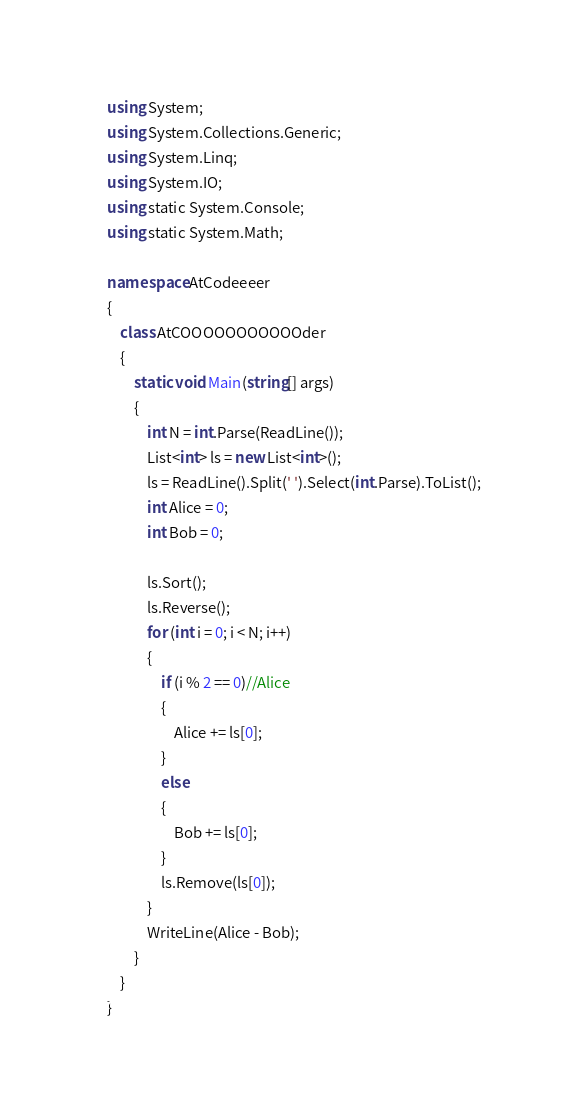<code> <loc_0><loc_0><loc_500><loc_500><_C#_>using System;
using System.Collections.Generic;
using System.Linq;
using System.IO;
using static System.Console;
using static System.Math;

namespace AtCodeeeer
{
    class AtCOOOOOOOOOOOder
    {
        static void Main(string[] args)
        {
            int N = int.Parse(ReadLine());
            List<int> ls = new List<int>();
            ls = ReadLine().Split(' ').Select(int.Parse).ToList();
            int Alice = 0;
            int Bob = 0;

            ls.Sort();
            ls.Reverse();
            for (int i = 0; i < N; i++)
            {
                if (i % 2 == 0)//Alice
                {
                    Alice += ls[0];
                }
                else
                {
                    Bob += ls[0];
                }
                ls.Remove(ls[0]);
            }
            WriteLine(Alice - Bob);
        }
    }
}
</code> 